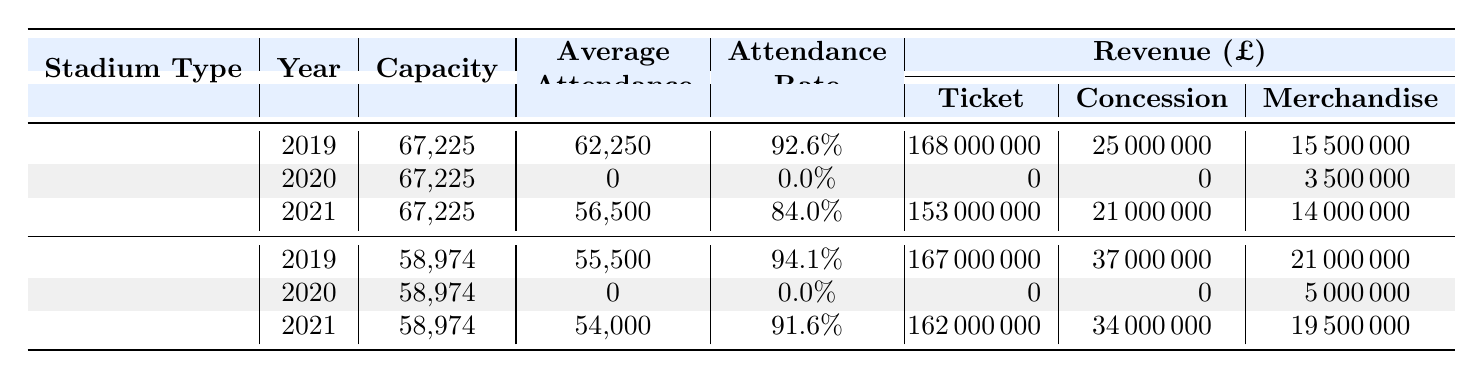What is the average capacity of traditional stadiums? The capacity of the traditional stadiums listed are: 74140 (Old Trafford), 74140 (Old Trafford), 74140 (Old Trafford), and 53394 (Anfield). To find the average, we add these capacities: 74140 + 74140 + 74140 + 53394 = 275814. There are 4 traditional stadiums, so the average capacity is 275814 / 4 = 68953.5.
Answer: 68953.5 What was the average attendance at modern stadiums in 2021? The average attendance at modern stadiums for 2021 is 54000 (Tottenham Hotspur Stadium) and 50000 (Etihad Stadium). To find the average, we sum these values: 54000 + 50000 = 104000. There are 2 modern stadiums, so the average attendance is 104000 / 2 = 52000.
Answer: 52000 Did traditional stadiums have higher ticket revenue than modern stadiums in 2019? In 2019, traditional stadiums had ticket revenue of 98000000 (Old Trafford) and 70000000 (Anfield), totaling 168000000. Modern stadiums had ticket revenue of 92000000 (Tottenham Hotspur Stadium) and 75000000 (Etihad Stadium), totaling 167000000. Comparing these totals, traditional stadiums generated 168000000 compared to 167000000 for modern stadiums, meaning traditional stadiums did have higher ticket revenue.
Answer: Yes What is the difference in average attendance between traditional and modern stadiums in 2021? In 2021, traditional stadiums had an average attendance of 56500 (calculated from Old Trafford's 65000 and Anfield's 48000) while modern stadiums had an average attendance of 54000. The difference between them is 56500 - 54000 = 2500.
Answer: 2500 Was there any year in which both stadium types had zero average attendance? Both traditional and modern stadiums recorded zero average attendance in 2020 for all stadiums listed. Therefore, there was indeed a year where both types had zero attendance.
Answer: Yes What was the total merchandise revenue for all traditional stadiums across the years? The merchandise revenue for traditional stadiums is: 8500000 (2019) + 2000000 (2020) + 7500000 (2021) = 18000000. Thus, the total merchandise revenue for all traditional stadiums across the years is 18000000.
Answer: 18000000 Which type of stadium had a higher average attendance rate in 2021? The average attendance rate for traditional stadiums in 2021 was 84.0% (based on 56500 attendance out of a 74140 capacity). For modern stadiums, it was 91.6% (based on 54000 attendance out of a 58974 capacity). Comparing these rates, modern stadiums had a higher average attendance rate of 91.6%.
Answer: Modern What is the total revenue (ticket + concession + merchandise) generated by traditional stadiums in 2019? The total revenue for traditional stadiums in 2019 is calculated as follows: ticket revenue of 98000000 + concession revenue of 15000000 + merchandise revenue of 8500000 = 121500000. This means the traditional stadiums generated a total revenue of 121500000 in that year.
Answer: 121500000 